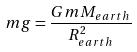Convert formula to latex. <formula><loc_0><loc_0><loc_500><loc_500>m g = \frac { G m M _ { e a r t h } } { R _ { e a r t h } ^ { 2 } }</formula> 